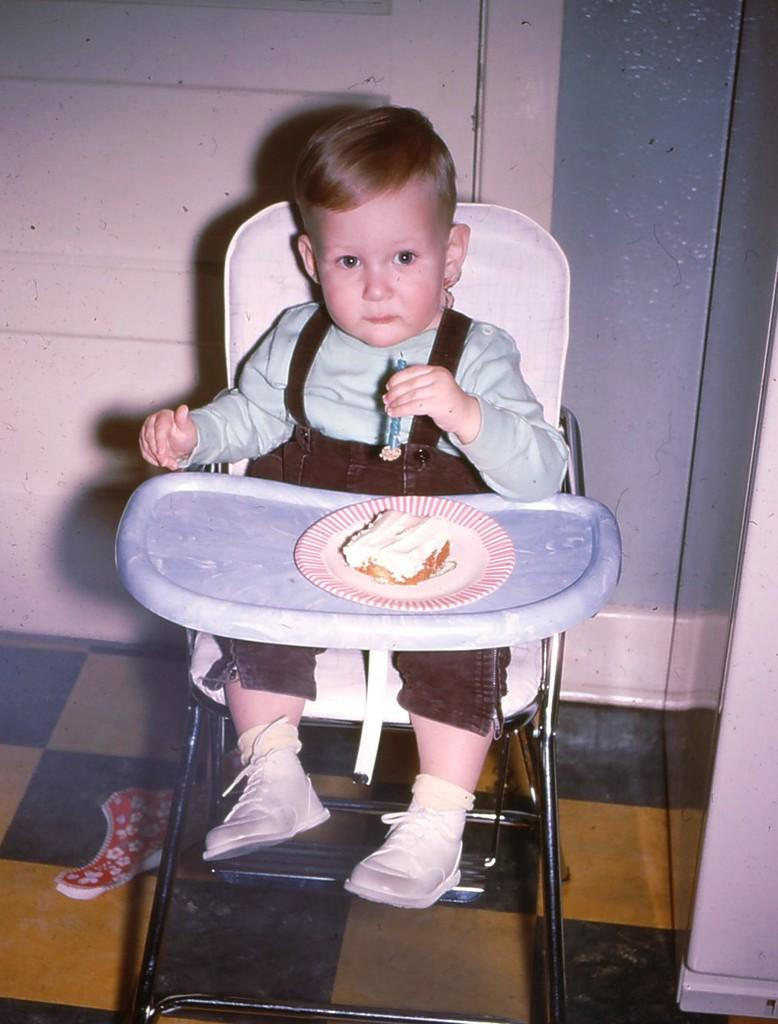What is the main subject of the picture? The main subject of the picture is a kid. How is the kid being emphasized in the image? The kid is highlighted in the image. What is the kid doing in the picture? The kid is sitting on a chair and eating a cake. What thrilling experience is the kid having while sitting on the chair? There is no indication of a thrilling experience in the image; the kid is simply sitting on a chair and eating a cake. Can you tell me where the writer is sitting in the image? There is no writer present in the image; it features a kid eating a cake. 